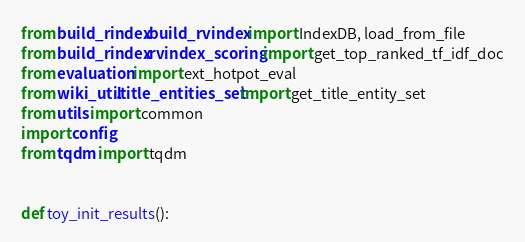Convert code to text. <code><loc_0><loc_0><loc_500><loc_500><_Python_>from build_rindex.build_rvindex import IndexDB, load_from_file
from build_rindex.rvindex_scoring import get_top_ranked_tf_idf_doc
from evaluation import ext_hotpot_eval
from wiki_util.title_entities_set import get_title_entity_set
from utils import common
import config
from tqdm import tqdm


def toy_init_results():</code> 